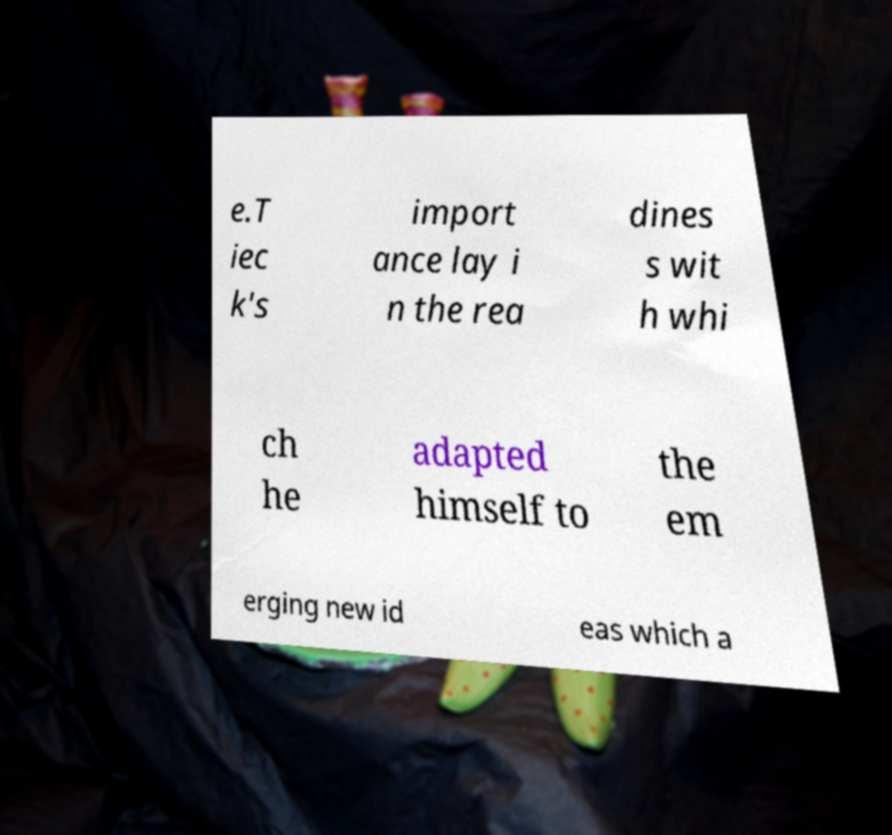Can you read and provide the text displayed in the image?This photo seems to have some interesting text. Can you extract and type it out for me? e.T iec k's import ance lay i n the rea dines s wit h whi ch he adapted himself to the em erging new id eas which a 